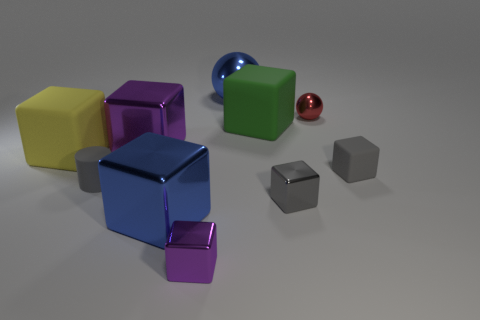Do the small purple metallic thing and the tiny gray shiny thing have the same shape?
Keep it short and to the point. Yes. What is the size of the gray shiny object that is the same shape as the green matte thing?
Offer a very short reply. Small. Are there any shiny blocks that have the same color as the big metallic ball?
Ensure brevity in your answer.  Yes. What material is the tiny cylinder that is the same color as the tiny rubber cube?
Your answer should be compact. Rubber. How many big shiny balls are the same color as the tiny metallic sphere?
Your answer should be compact. 0. How many things are either large shiny objects that are in front of the large purple thing or big yellow matte things?
Offer a terse response. 2. There is a big cube that is the same material as the big purple thing; what color is it?
Your answer should be compact. Blue. Is there a yellow metal sphere of the same size as the cylinder?
Your answer should be very brief. No. What number of things are large blue metallic cubes that are left of the red metal object or gray objects that are behind the small gray shiny cube?
Your response must be concise. 3. There is a purple metallic thing that is the same size as the red object; what shape is it?
Your response must be concise. Cube. 